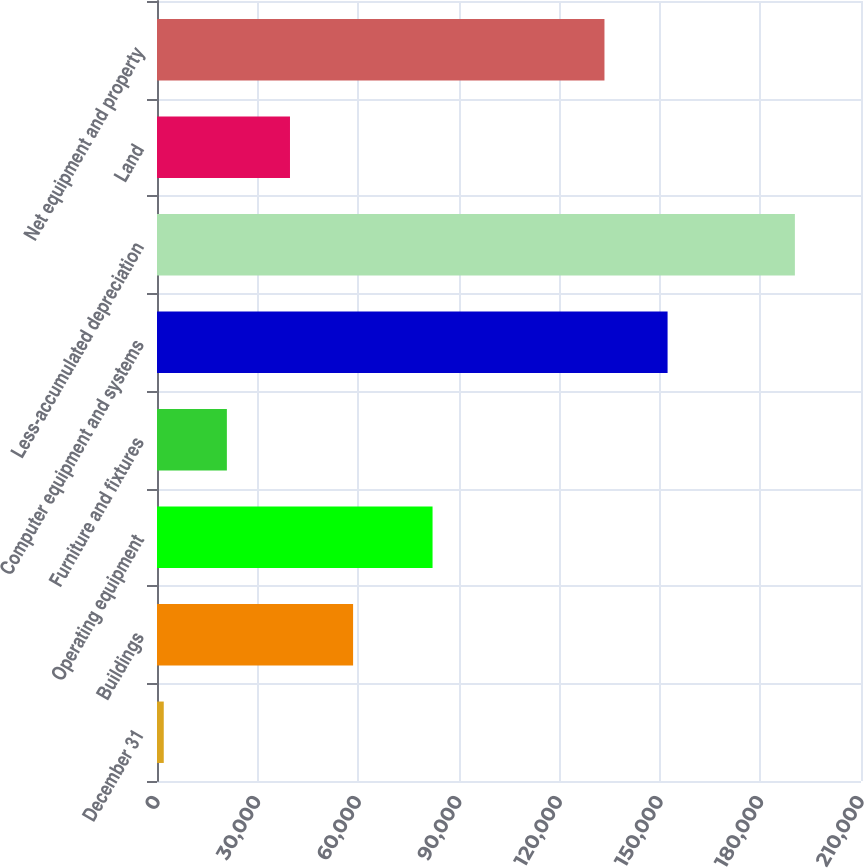<chart> <loc_0><loc_0><loc_500><loc_500><bar_chart><fcel>December 31<fcel>Buildings<fcel>Operating equipment<fcel>Furniture and fixtures<fcel>Computer equipment and systems<fcel>Less-accumulated depreciation<fcel>Land<fcel>Net equipment and property<nl><fcel>2016<fcel>58494.9<fcel>82196<fcel>20842.3<fcel>152303<fcel>190279<fcel>39668.6<fcel>133477<nl></chart> 